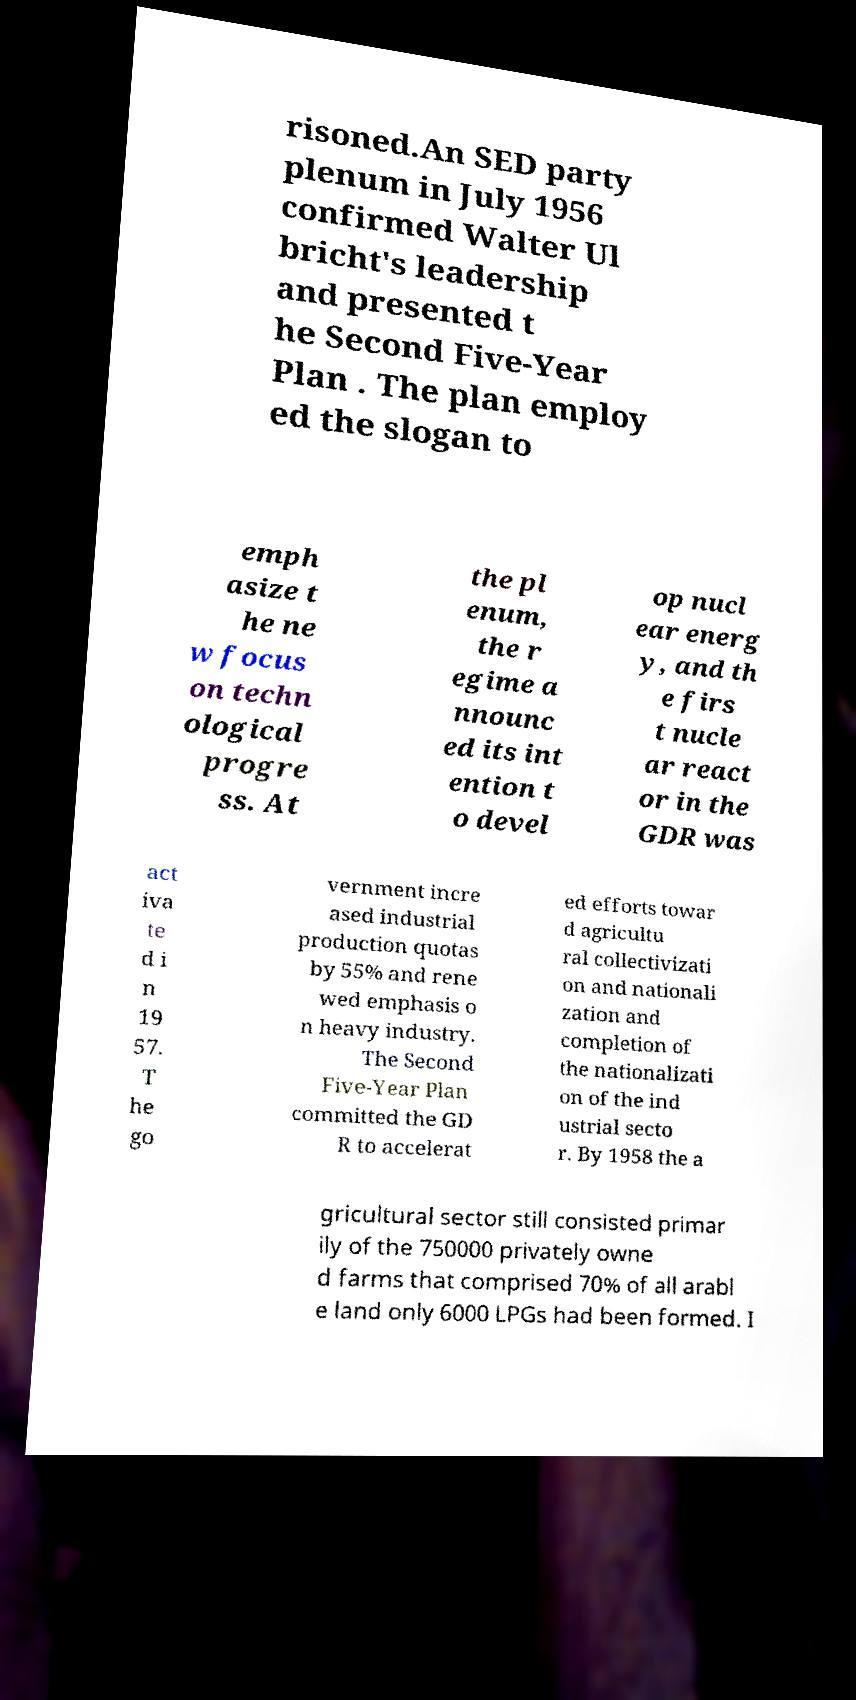Please read and relay the text visible in this image. What does it say? risoned.An SED party plenum in July 1956 confirmed Walter Ul bricht's leadership and presented t he Second Five-Year Plan . The plan employ ed the slogan to emph asize t he ne w focus on techn ological progre ss. At the pl enum, the r egime a nnounc ed its int ention t o devel op nucl ear energ y, and th e firs t nucle ar react or in the GDR was act iva te d i n 19 57. T he go vernment incre ased industrial production quotas by 55% and rene wed emphasis o n heavy industry. The Second Five-Year Plan committed the GD R to accelerat ed efforts towar d agricultu ral collectivizati on and nationali zation and completion of the nationalizati on of the ind ustrial secto r. By 1958 the a gricultural sector still consisted primar ily of the 750000 privately owne d farms that comprised 70% of all arabl e land only 6000 LPGs had been formed. I 